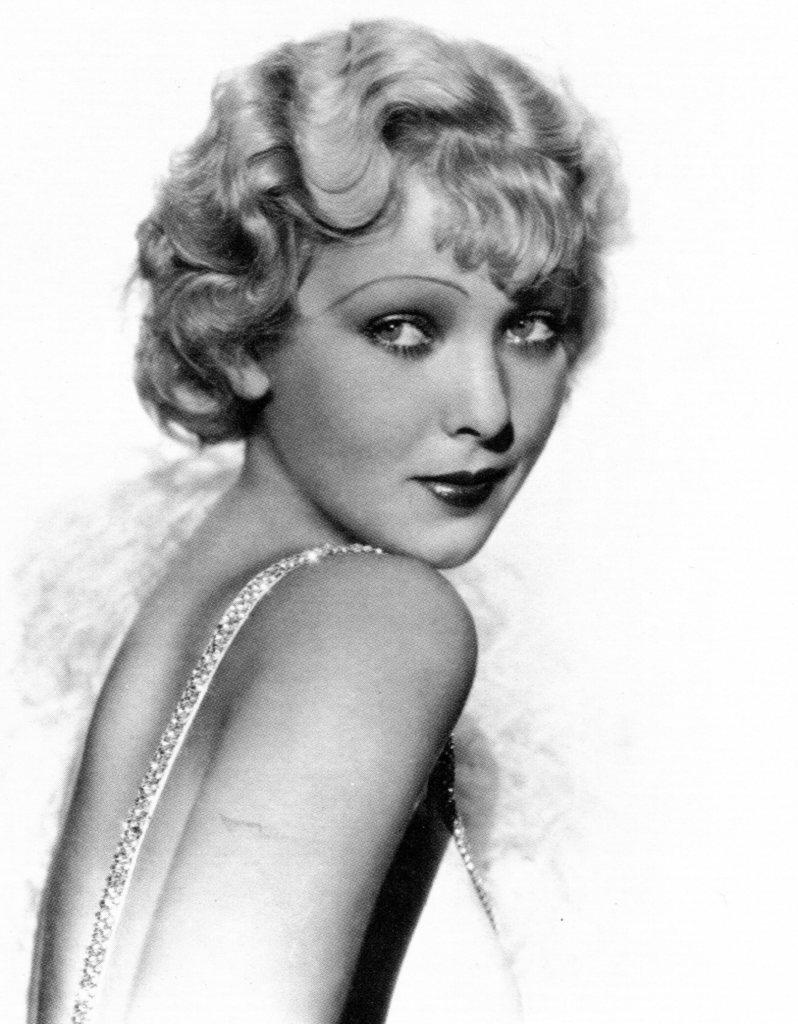What is the color scheme of the image? The image is black and white. What is the main subject of the image? There is a picture of a woman in the image. What type of car is parked next to the woman in the image? There is no car present in the image; it only features a picture of a woman. What event is the woman attending in the image? There is no indication of an event in the image, as it only shows a picture of a woman. 